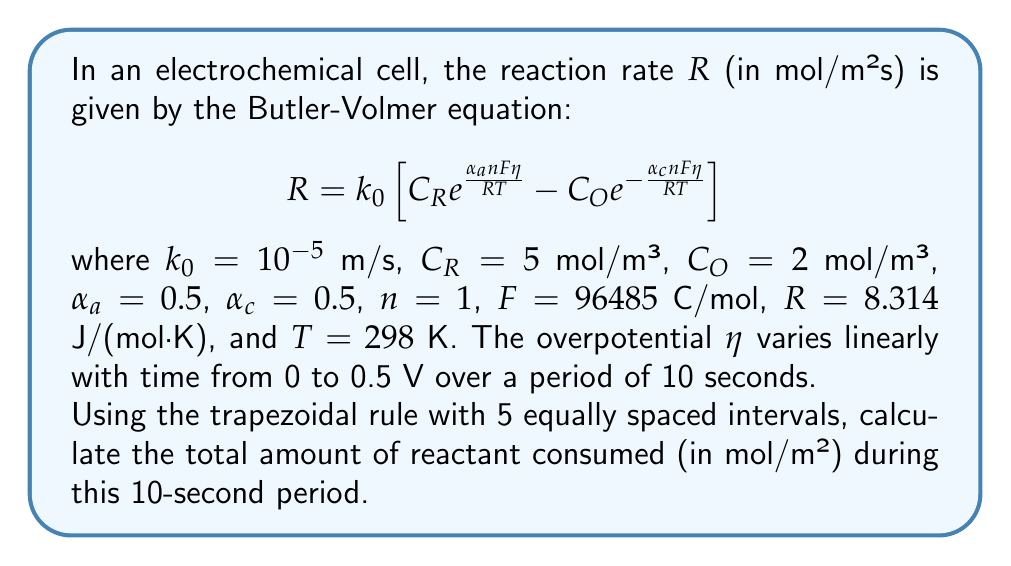Can you answer this question? To solve this problem, we need to follow these steps:

1) First, we need to set up the trapezoidal rule for numerical integration. The formula is:

   $$\int_{a}^{b} f(x) dx \approx \frac{h}{2} \left[f(x_0) + 2f(x_1) + 2f(x_2) + ... + 2f(x_{n-1}) + f(x_n)\right]$$

   where $h = (b-a)/n$, and $n$ is the number of intervals.

2) In our case, we're integrating over time from 0 to 10 seconds, with 5 intervals. So $h = (10-0)/5 = 2$ seconds.

3) We need to calculate the reaction rate $R$ at 6 points: $t = 0, 2, 4, 6, 8,$ and $10$ seconds.

4) At each point, we need to calculate the overpotential $\eta$. Since $\eta$ varies linearly from 0 to 0.5 V over 10 seconds, we can use the equation:

   $$\eta = 0.05t$$ where $t$ is in seconds.

5) Now, let's calculate $R$ for each point:

   At $t = 0$ s: $\eta = 0$ V
   $$R_0 = 10^{-5} \left[ 5 e^{\frac{0.5 \cdot 1 \cdot 96485 \cdot 0}{8.314 \cdot 298}} - 2 e^{-\frac{0.5 \cdot 1 \cdot 96485 \cdot 0}{8.314 \cdot 298}} \right] = 3 \times 10^{-5}$$

   At $t = 2$ s: $\eta = 0.1$ V
   $$R_1 = 10^{-5} \left[ 5 e^{\frac{0.5 \cdot 1 \cdot 96485 \cdot 0.1}{8.314 \cdot 298}} - 2 e^{-\frac{0.5 \cdot 1 \cdot 96485 \cdot 0.1}{8.314 \cdot 298}} \right] = 1.92 \times 10^{-4}$$

   At $t = 4$ s: $\eta = 0.2$ V
   $$R_2 = 10^{-5} \left[ 5 e^{\frac{0.5 \cdot 1 \cdot 96485 \cdot 0.2}{8.314 \cdot 298}} - 2 e^{-\frac{0.5 \cdot 1 \cdot 96485 \cdot 0.2}{8.314 \cdot 298}} \right] = 1.22 \times 10^{-3}$$

   At $t = 6$ s: $\eta = 0.3$ V
   $$R_3 = 10^{-5} \left[ 5 e^{\frac{0.5 \cdot 1 \cdot 96485 \cdot 0.3}{8.314 \cdot 298}} - 2 e^{-\frac{0.5 \cdot 1 \cdot 96485 \cdot 0.3}{8.314 \cdot 298}} \right] = 7.74 \times 10^{-3}$$

   At $t = 8$ s: $\eta = 0.4$ V
   $$R_4 = 10^{-5} \left[ 5 e^{\frac{0.5 \cdot 1 \cdot 96485 \cdot 0.4}{8.314 \cdot 298}} - 2 e^{-\frac{0.5 \cdot 1 \cdot 96485 \cdot 0.4}{8.314 \cdot 298}} \right] = 4.91 \times 10^{-2}$$

   At $t = 10$ s: $\eta = 0.5$ V
   $$R_5 = 10^{-5} \left[ 5 e^{\frac{0.5 \cdot 1 \cdot 96485 \cdot 0.5}{8.314 \cdot 298}} - 2 e^{-\frac{0.5 \cdot 1 \cdot 96485 \cdot 0.5}{8.314 \cdot 298}} \right] = 0.311$$

6) Now we can apply the trapezoidal rule:

   $$\int_{0}^{10} R dt \approx \frac{2}{2} \left[R_0 + 2R_1 + 2R_2 + 2R_3 + 2R_4 + R_5\right]$$

   $$= 1 \left[3 \times 10^{-5} + 2(1.92 \times 10^{-4}) + 2(1.22 \times 10^{-3}) + 2(7.74 \times 10^{-3}) + 2(4.91 \times 10^{-2}) + 0.311\right]$$

   $$= 0.419 \text{ mol/m²}$$

This is the total amount of reactant consumed over the 10-second period.
Answer: 0.419 mol/m² 